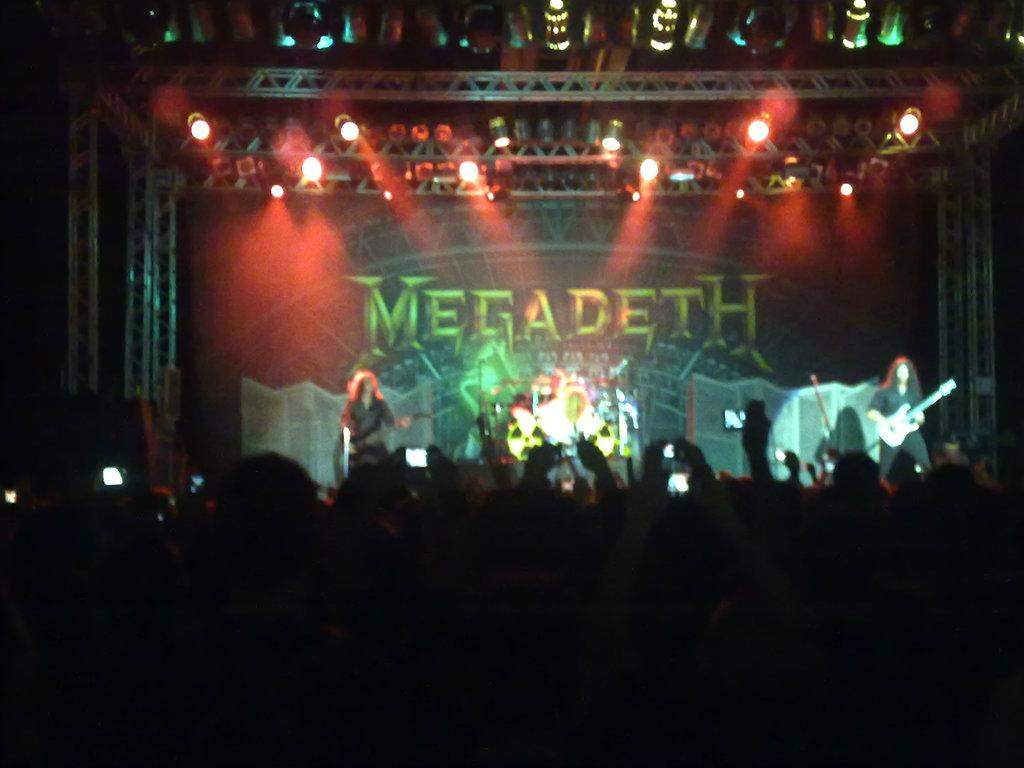What is happening on the stage in the image? There are people performing on the stage in the image. What can be seen at the top of the image? There are focused lights at the top of the image. What type of chess piece is being used as a prop by the performers on the stage? There is no chess piece visible in the image, and the performers are not using any props. 